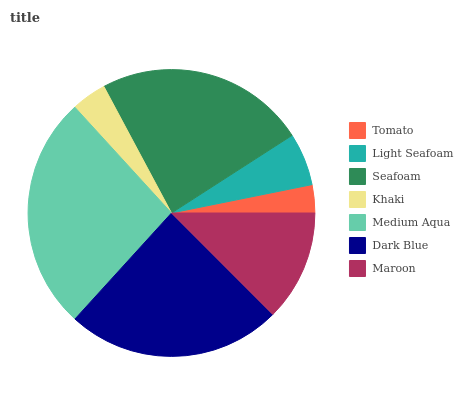Is Tomato the minimum?
Answer yes or no. Yes. Is Medium Aqua the maximum?
Answer yes or no. Yes. Is Light Seafoam the minimum?
Answer yes or no. No. Is Light Seafoam the maximum?
Answer yes or no. No. Is Light Seafoam greater than Tomato?
Answer yes or no. Yes. Is Tomato less than Light Seafoam?
Answer yes or no. Yes. Is Tomato greater than Light Seafoam?
Answer yes or no. No. Is Light Seafoam less than Tomato?
Answer yes or no. No. Is Maroon the high median?
Answer yes or no. Yes. Is Maroon the low median?
Answer yes or no. Yes. Is Tomato the high median?
Answer yes or no. No. Is Light Seafoam the low median?
Answer yes or no. No. 